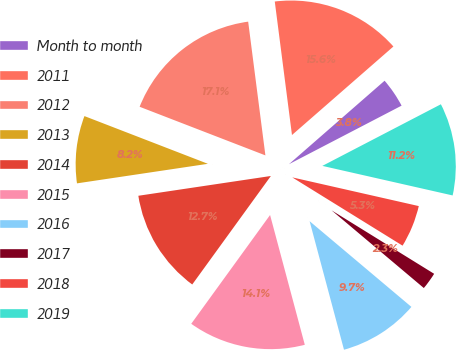<chart> <loc_0><loc_0><loc_500><loc_500><pie_chart><fcel>Month to month<fcel>2011<fcel>2012<fcel>2013<fcel>2014<fcel>2015<fcel>2016<fcel>2017<fcel>2018<fcel>2019<nl><fcel>3.79%<fcel>15.62%<fcel>17.09%<fcel>8.23%<fcel>12.66%<fcel>14.14%<fcel>9.7%<fcel>2.32%<fcel>5.27%<fcel>11.18%<nl></chart> 